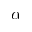<formula> <loc_0><loc_0><loc_500><loc_500>\alpha</formula> 